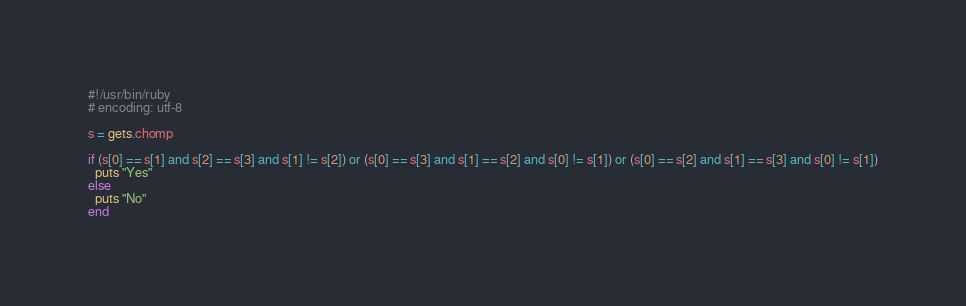Convert code to text. <code><loc_0><loc_0><loc_500><loc_500><_Ruby_>#!/usr/bin/ruby
# encoding: utf-8

s = gets.chomp

if (s[0] == s[1] and s[2] == s[3] and s[1] != s[2]) or (s[0] == s[3] and s[1] == s[2] and s[0] != s[1]) or (s[0] == s[2] and s[1] == s[3] and s[0] != s[1])
  puts "Yes"
else
  puts "No"
end</code> 